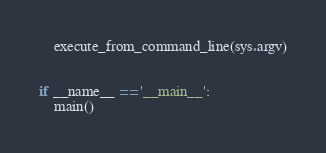Convert code to text. <code><loc_0><loc_0><loc_500><loc_500><_Python_>    execute_from_command_line(sys.argv)


if __name__ == '__main__':
    main()
</code> 